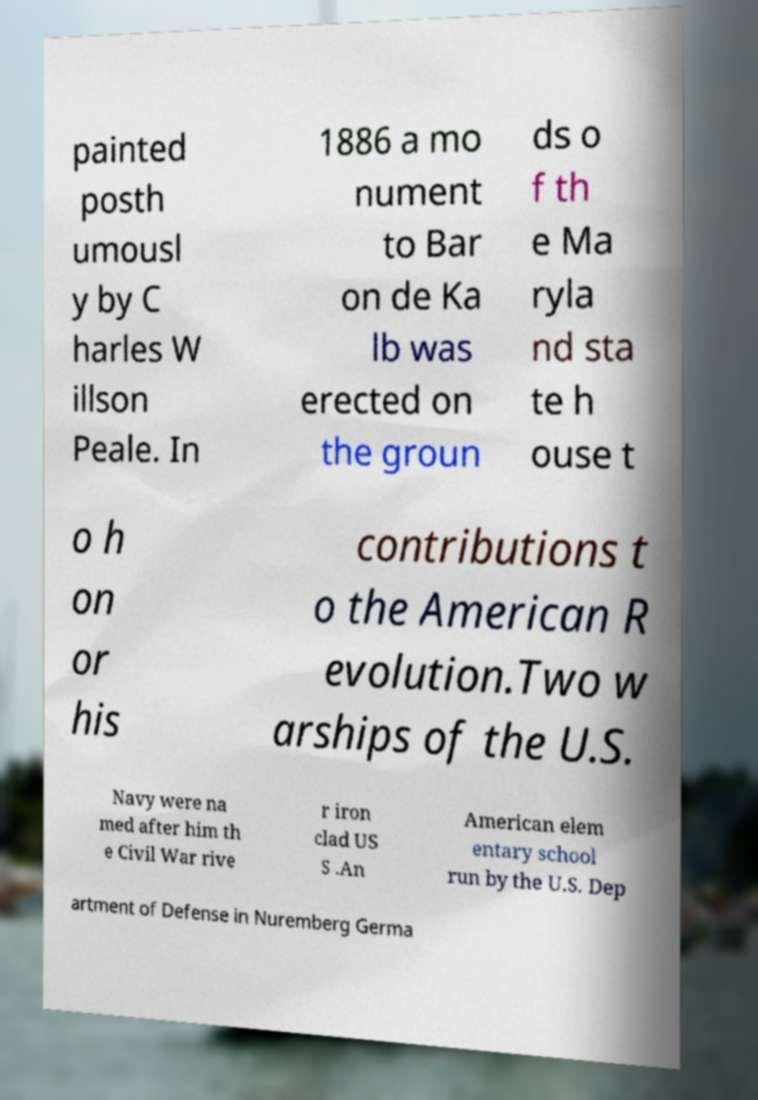Could you extract and type out the text from this image? painted posth umousl y by C harles W illson Peale. In 1886 a mo nument to Bar on de Ka lb was erected on the groun ds o f th e Ma ryla nd sta te h ouse t o h on or his contributions t o the American R evolution.Two w arships of the U.S. Navy were na med after him th e Civil War rive r iron clad US S .An American elem entary school run by the U.S. Dep artment of Defense in Nuremberg Germa 